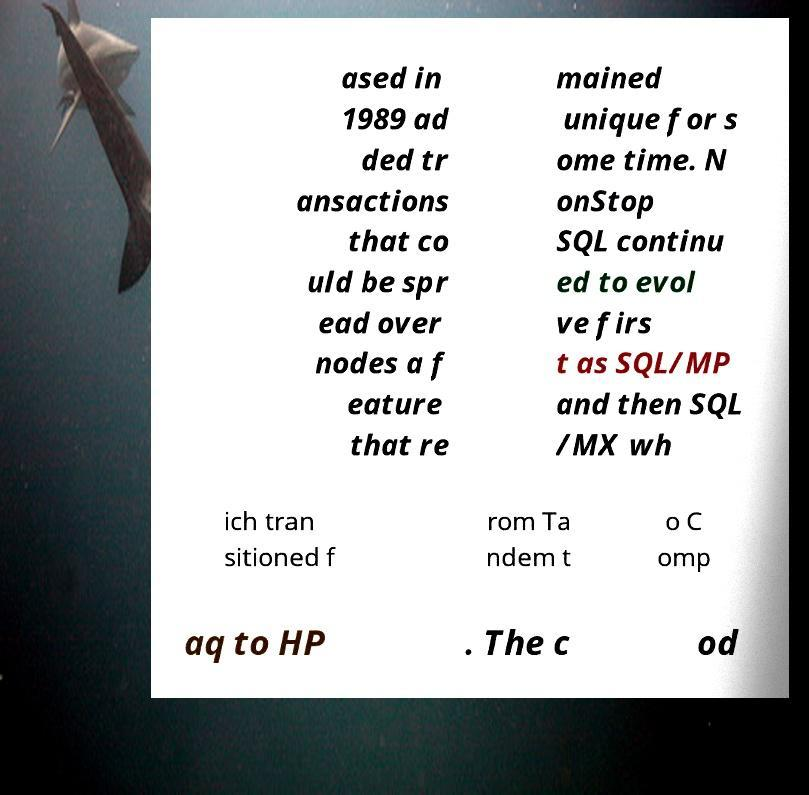What messages or text are displayed in this image? I need them in a readable, typed format. ased in 1989 ad ded tr ansactions that co uld be spr ead over nodes a f eature that re mained unique for s ome time. N onStop SQL continu ed to evol ve firs t as SQL/MP and then SQL /MX wh ich tran sitioned f rom Ta ndem t o C omp aq to HP . The c od 